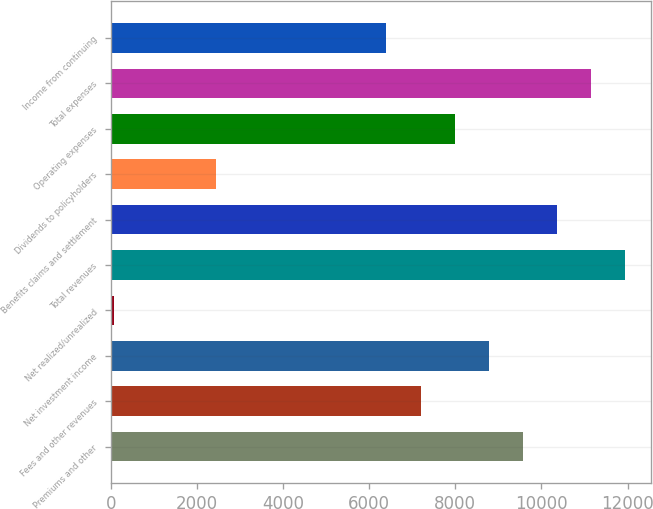Convert chart to OTSL. <chart><loc_0><loc_0><loc_500><loc_500><bar_chart><fcel>Premiums and other<fcel>Fees and other revenues<fcel>Net investment income<fcel>Net realized/unrealized<fcel>Total revenues<fcel>Benefits claims and settlement<fcel>Dividends to policyholders<fcel>Operating expenses<fcel>Total expenses<fcel>Income from continuing<nl><fcel>9566.6<fcel>7190.75<fcel>8774.65<fcel>63.2<fcel>11942.5<fcel>10358.5<fcel>2439.05<fcel>7982.7<fcel>11150.5<fcel>6398.8<nl></chart> 